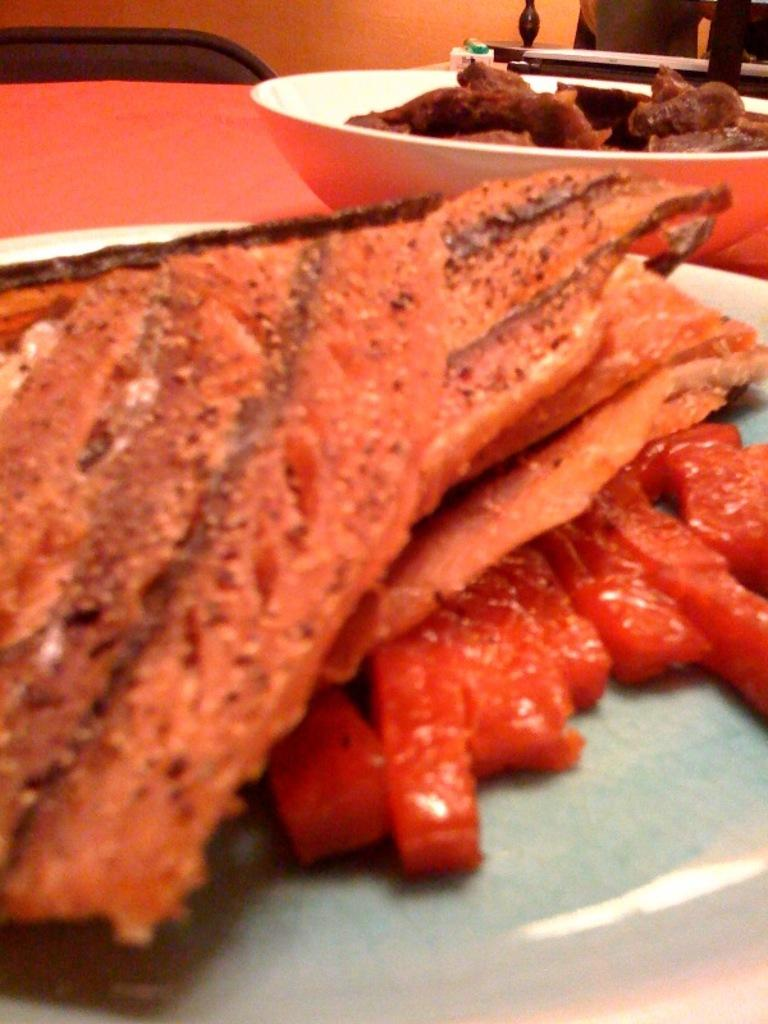What type of container is holding food in the image? There is food in a bowl in the image. What other type of container is holding food in the image? There is food on a plate in the image. Where are the bowl and plate located? The bowl and plate are on a table in the image. What type of furniture is present in the image? There is a chair in the image. What arithmetic problem is being solved on the tongue in the image? There is no arithmetic problem or tongue present in the image. What type of cover is placed over the food in the image? There is no cover placed over the food in the image. 